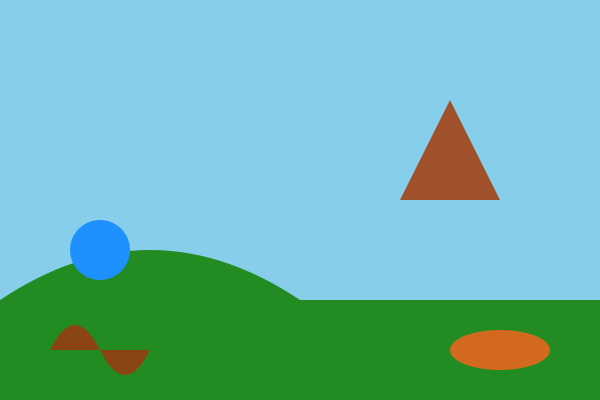Match the following Icelandic mythological creatures to their likely habitats in the landscape:

1. Huldufólk (Hidden People)
2. Nykur (Water Horse)
3. Jötunn (Giant)
4. Draugr (Undead)

A. Mountain
B. Lake
C. Hill
D. Cave To match the Icelandic mythological creatures to their likely habitats, we need to consider their traditional characteristics and the landscape elements shown in the illustration:

1. Huldufólk (Hidden People):
   - Known to live in rocks, hills, and mounds
   - The illustration shows a small hill-like formation
   - Best match: C. Hill

2. Nykur (Water Horse):
   - Associated with bodies of water
   - The illustration includes a blue circular area representing a lake
   - Best match: B. Lake

3. Jötunn (Giant):
   - Often associated with mountains and wild landscapes
   - The illustration shows a triangular mountain-like formation
   - Best match: A. Mountain

4. Draugr (Undead):
   - Often associated with burial mounds and dark, enclosed spaces
   - The illustration shows a cave-like formation at the base of the landscape
   - Best match: D. Cave

By considering the characteristics of each creature and the elements present in the landscape, we can accurately match them to their most likely habitats.
Answer: 1-C, 2-B, 3-A, 4-D 